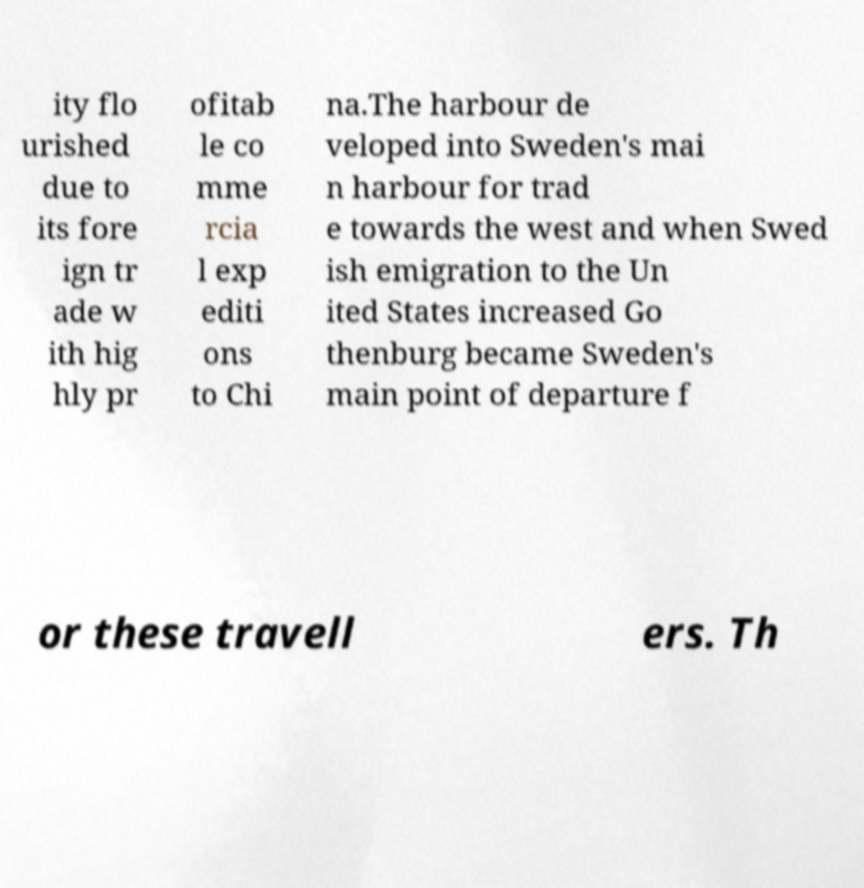Can you read and provide the text displayed in the image?This photo seems to have some interesting text. Can you extract and type it out for me? ity flo urished due to its fore ign tr ade w ith hig hly pr ofitab le co mme rcia l exp editi ons to Chi na.The harbour de veloped into Sweden's mai n harbour for trad e towards the west and when Swed ish emigration to the Un ited States increased Go thenburg became Sweden's main point of departure f or these travell ers. Th 